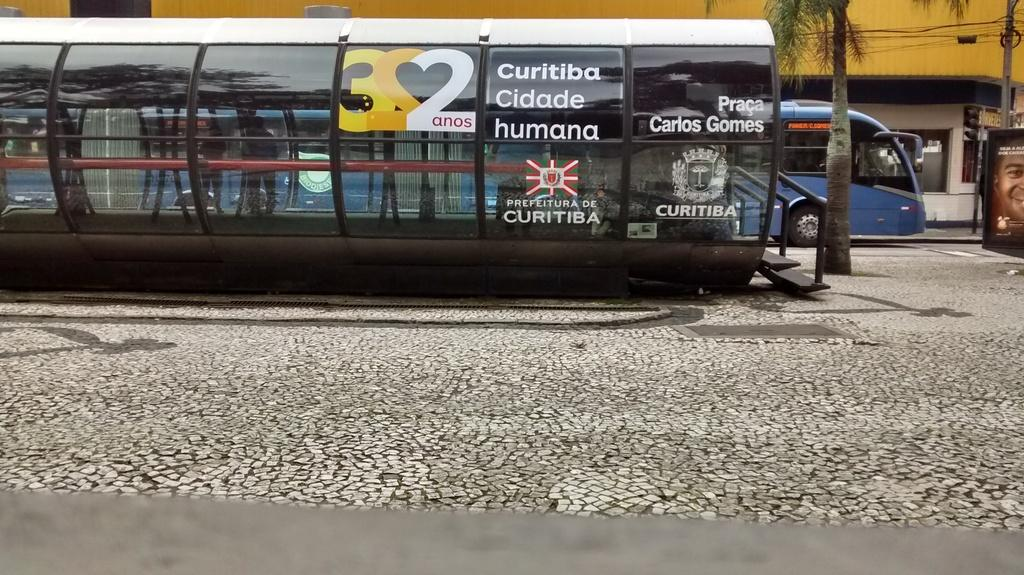<image>
Relay a brief, clear account of the picture shown. A covered bench space has a number 322 formed into a heart shaped using the mirror image of the 2s 